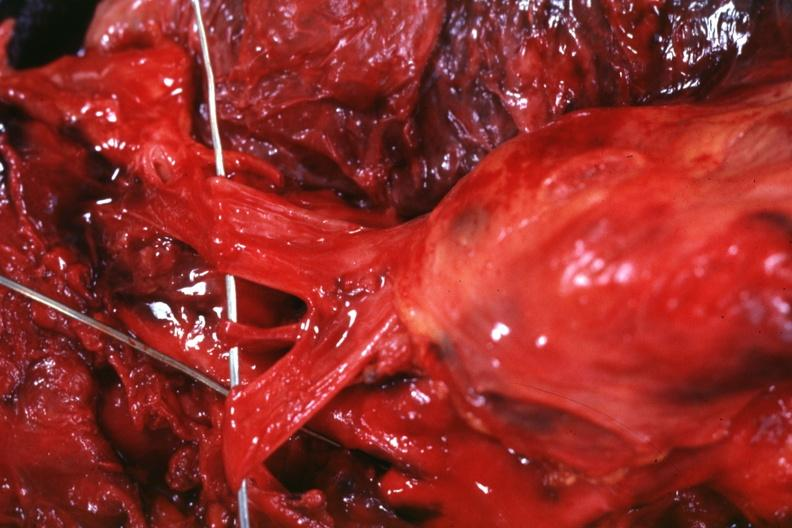what is present?
Answer the question using a single word or phrase. Thymus 